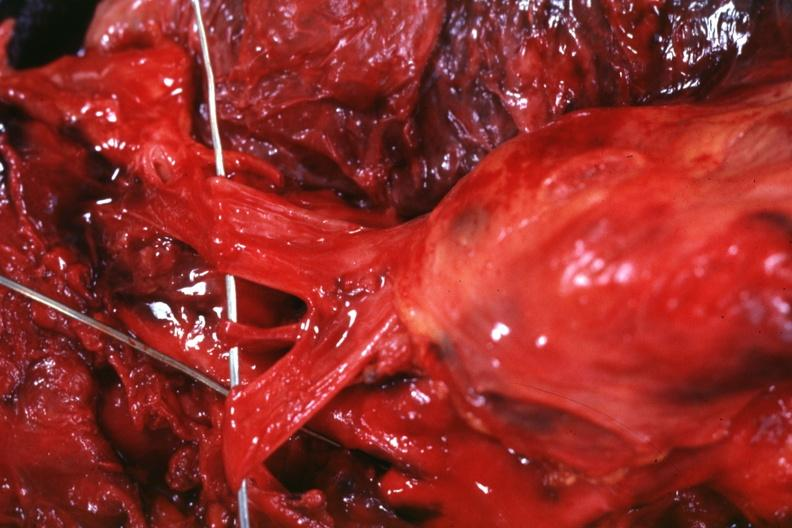what is present?
Answer the question using a single word or phrase. Thymus 